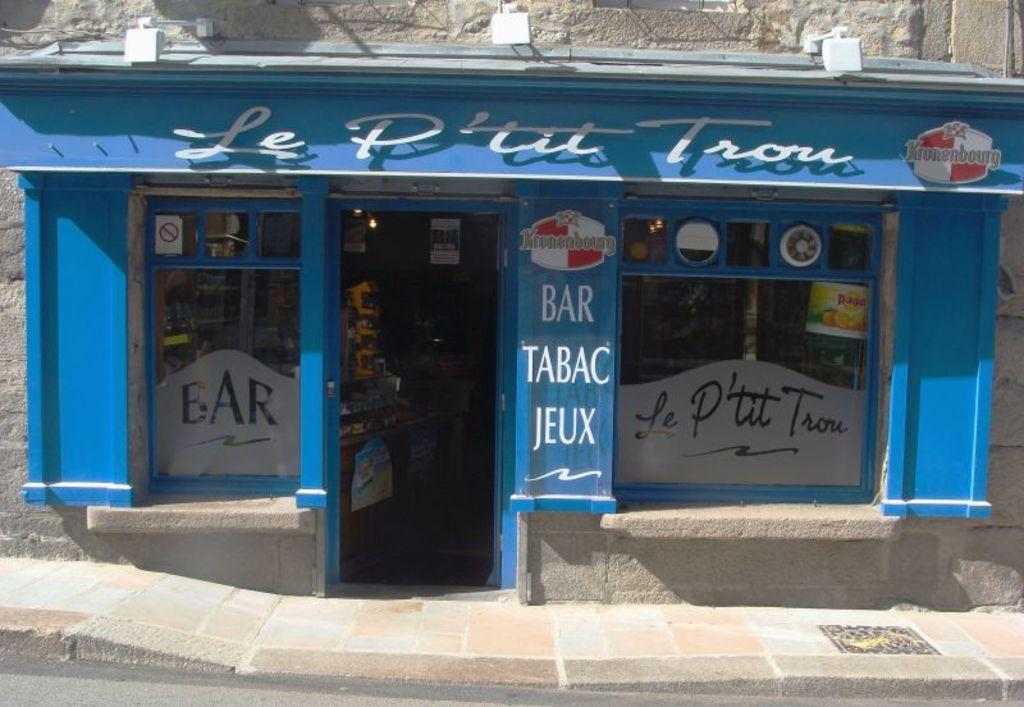What type of establishment is shown in the image? There is a shop in the image. How can the name of the shop be identified? The shop has a name board at the front part. What is illuminating the name board? There are lights near the name board. What part of the shop's structure is visible? The wall of the shop is visible. What type of surface is visible in front of the shop? The pavement is visible in the image. How does the shop attract the attention of passing sailboats? The image does not show any sailboats, and there is no indication that the shop is trying to attract their attention. 